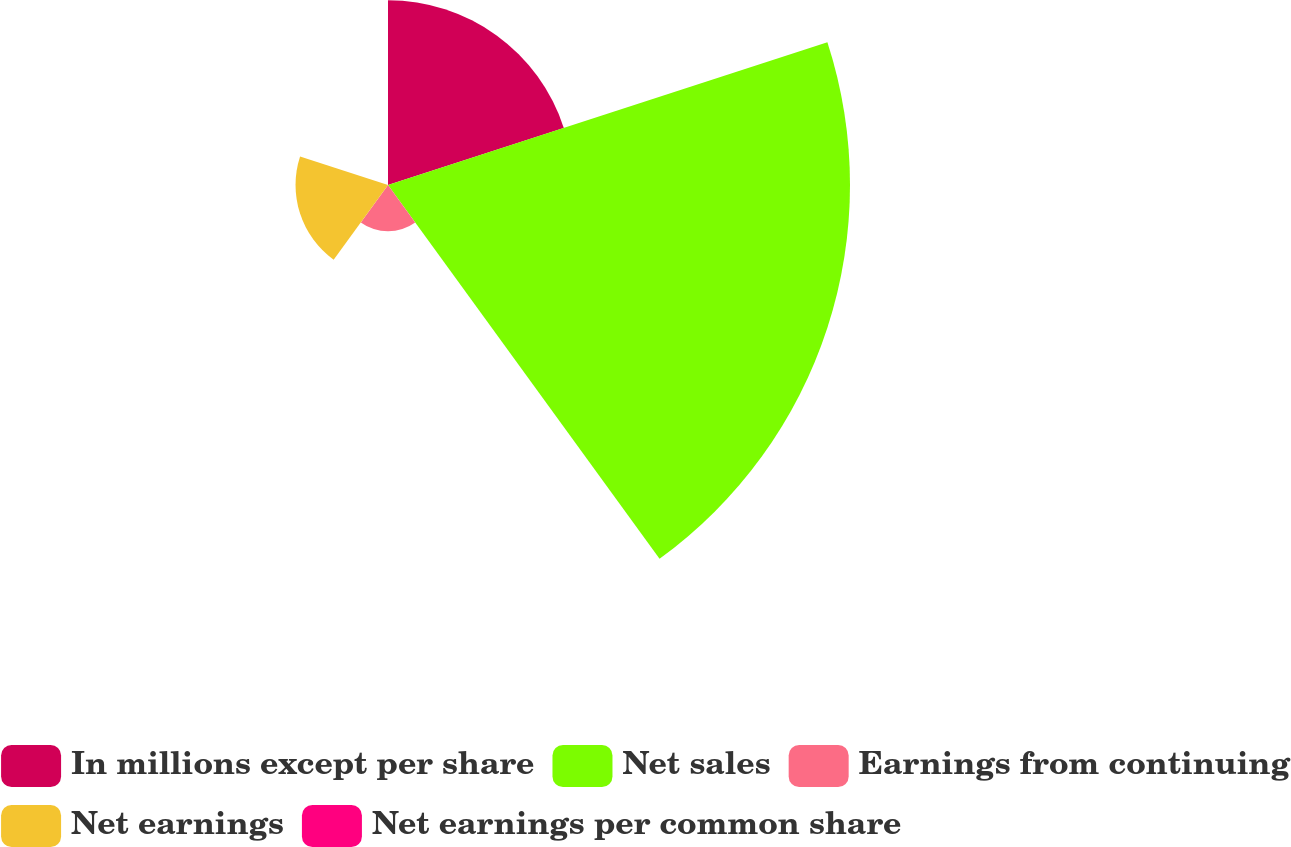<chart> <loc_0><loc_0><loc_500><loc_500><pie_chart><fcel>In millions except per share<fcel>Net sales<fcel>Earnings from continuing<fcel>Net earnings<fcel>Net earnings per common share<nl><fcel>23.53%<fcel>58.81%<fcel>5.89%<fcel>11.77%<fcel>0.01%<nl></chart> 